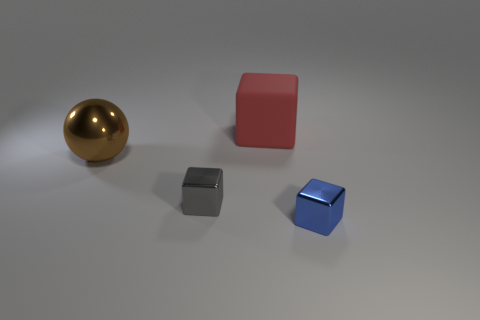Add 4 small blue things. How many objects exist? 8 Subtract all cubes. How many objects are left? 1 Subtract 1 brown balls. How many objects are left? 3 Subtract all large cyan rubber objects. Subtract all large metallic spheres. How many objects are left? 3 Add 1 red blocks. How many red blocks are left? 2 Add 2 gray things. How many gray things exist? 3 